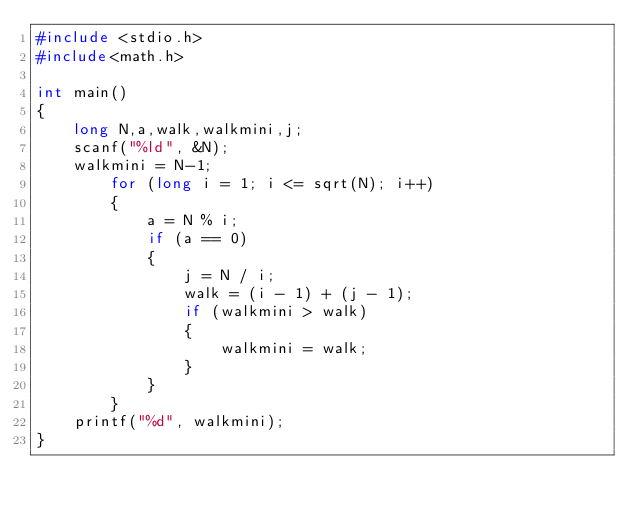<code> <loc_0><loc_0><loc_500><loc_500><_C_>#include <stdio.h>
#include<math.h>

int main()
{
	long N,a,walk,walkmini,j;
	scanf("%ld", &N);
	walkmini = N-1;
		for (long i = 1; i <= sqrt(N); i++)
		{
			a = N % i;
			if (a == 0)
			{
				j = N / i;
				walk = (i - 1) + (j - 1);
				if (walkmini > walk)
				{
					walkmini = walk;
				}
			}
		}
	printf("%d", walkmini);
}</code> 